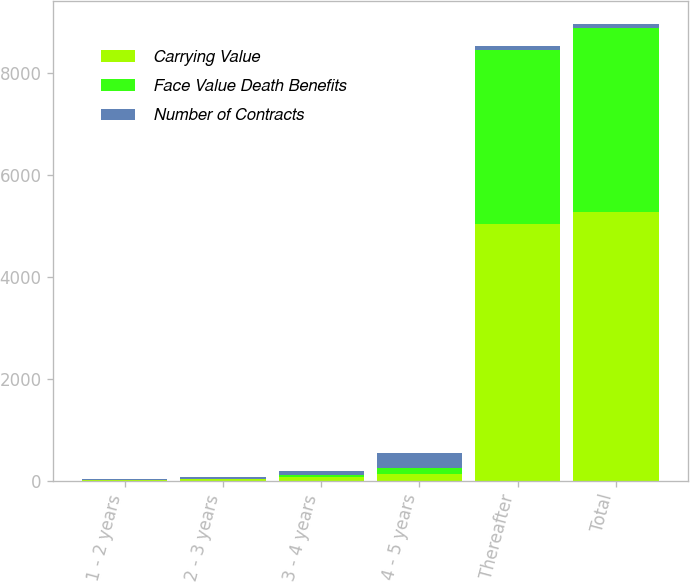<chart> <loc_0><loc_0><loc_500><loc_500><stacked_bar_chart><ecel><fcel>1 - 2 years<fcel>2 - 3 years<fcel>3 - 4 years<fcel>4 - 5 years<fcel>Thereafter<fcel>Total<nl><fcel>Carrying Value<fcel>9<fcel>26<fcel>72<fcel>138<fcel>5030<fcel>5276<nl><fcel>Face Value Death Benefits<fcel>5<fcel>14<fcel>41<fcel>119<fcel>3422<fcel>3601<nl><fcel>Number of Contracts<fcel>10<fcel>29<fcel>84<fcel>289<fcel>78<fcel>78<nl></chart> 